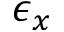<formula> <loc_0><loc_0><loc_500><loc_500>\epsilon _ { x }</formula> 